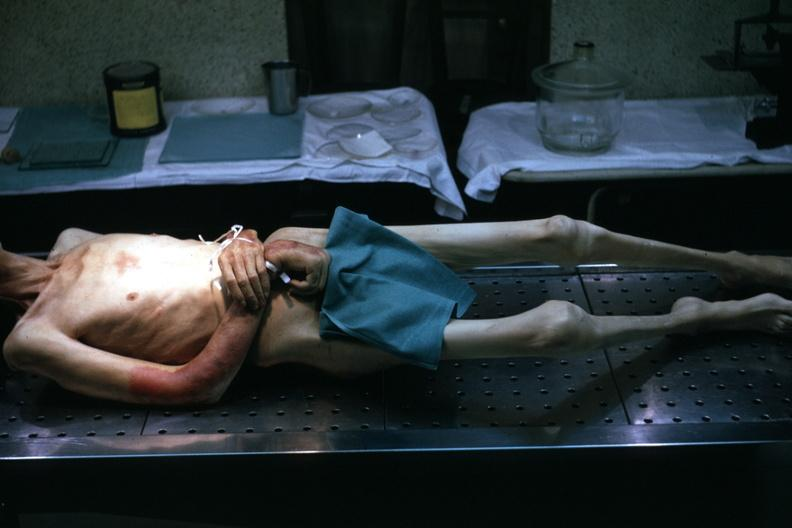what is striking?
Answer the question using a single word or phrase. Muscle atrophy 